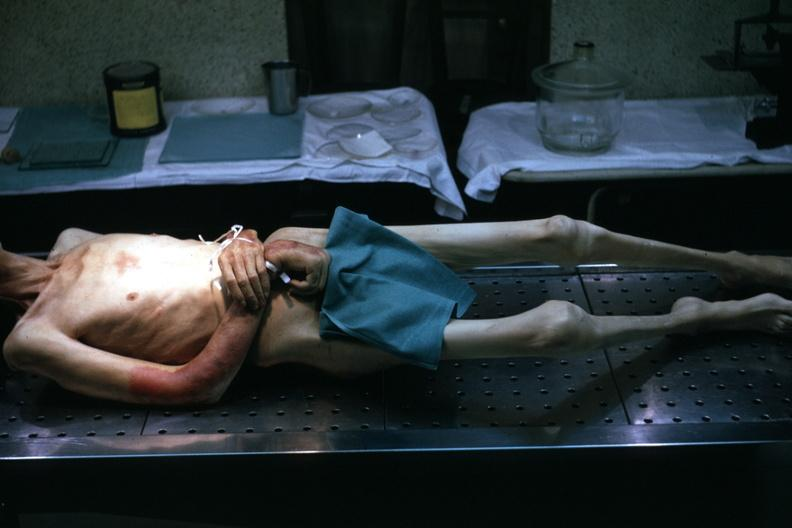what is striking?
Answer the question using a single word or phrase. Muscle atrophy 